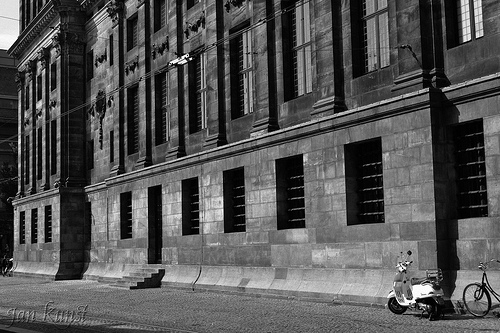What story do you think this building might have? Be very creative! This building, once the grand Royal Library, held ancient scrolls and books filled with the world's secrets, ancient spells, and forgotten histories. At night, the windows would glow with a supernatural light as the spirits of scholars long past would roam, continuing their eternal quest for knowledge. The stairs used to lead to a hidden underground chamber where a portal to another dimension was said to reside. It's whispered among the locals that the bicycle belongs to the guardian of the library, a timeless being who ensures the knowledge within remains protected and undisturbed. 